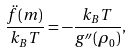Convert formula to latex. <formula><loc_0><loc_0><loc_500><loc_500>\frac { \ddot { f } ( m ) } { k _ { B } T } = - \frac { k _ { B } T } { g ^ { \prime \prime } ( \rho _ { 0 } ) } ,</formula> 